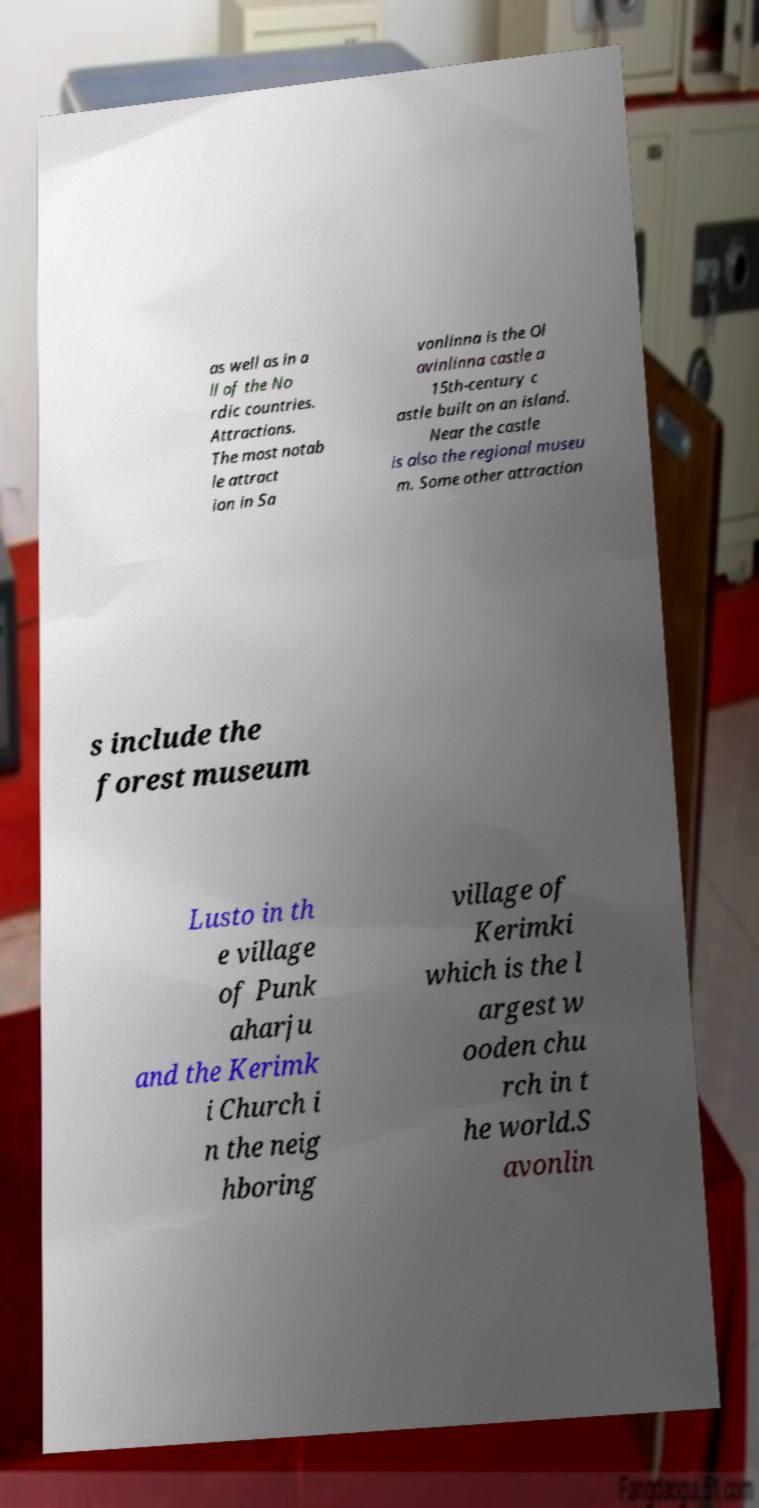There's text embedded in this image that I need extracted. Can you transcribe it verbatim? as well as in a ll of the No rdic countries. Attractions. The most notab le attract ion in Sa vonlinna is the Ol avinlinna castle a 15th-century c astle built on an island. Near the castle is also the regional museu m. Some other attraction s include the forest museum Lusto in th e village of Punk aharju and the Kerimk i Church i n the neig hboring village of Kerimki which is the l argest w ooden chu rch in t he world.S avonlin 